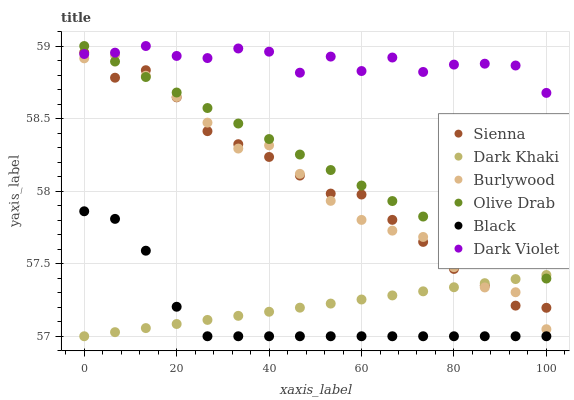Does Black have the minimum area under the curve?
Answer yes or no. Yes. Does Dark Violet have the maximum area under the curve?
Answer yes or no. Yes. Does Burlywood have the minimum area under the curve?
Answer yes or no. No. Does Burlywood have the maximum area under the curve?
Answer yes or no. No. Is Olive Drab the smoothest?
Answer yes or no. Yes. Is Dark Violet the roughest?
Answer yes or no. Yes. Is Burlywood the smoothest?
Answer yes or no. No. Is Burlywood the roughest?
Answer yes or no. No. Does Dark Khaki have the lowest value?
Answer yes or no. Yes. Does Burlywood have the lowest value?
Answer yes or no. No. Does Olive Drab have the highest value?
Answer yes or no. Yes. Does Burlywood have the highest value?
Answer yes or no. No. Is Black less than Sienna?
Answer yes or no. Yes. Is Burlywood greater than Black?
Answer yes or no. Yes. Does Sienna intersect Olive Drab?
Answer yes or no. Yes. Is Sienna less than Olive Drab?
Answer yes or no. No. Is Sienna greater than Olive Drab?
Answer yes or no. No. Does Black intersect Sienna?
Answer yes or no. No. 